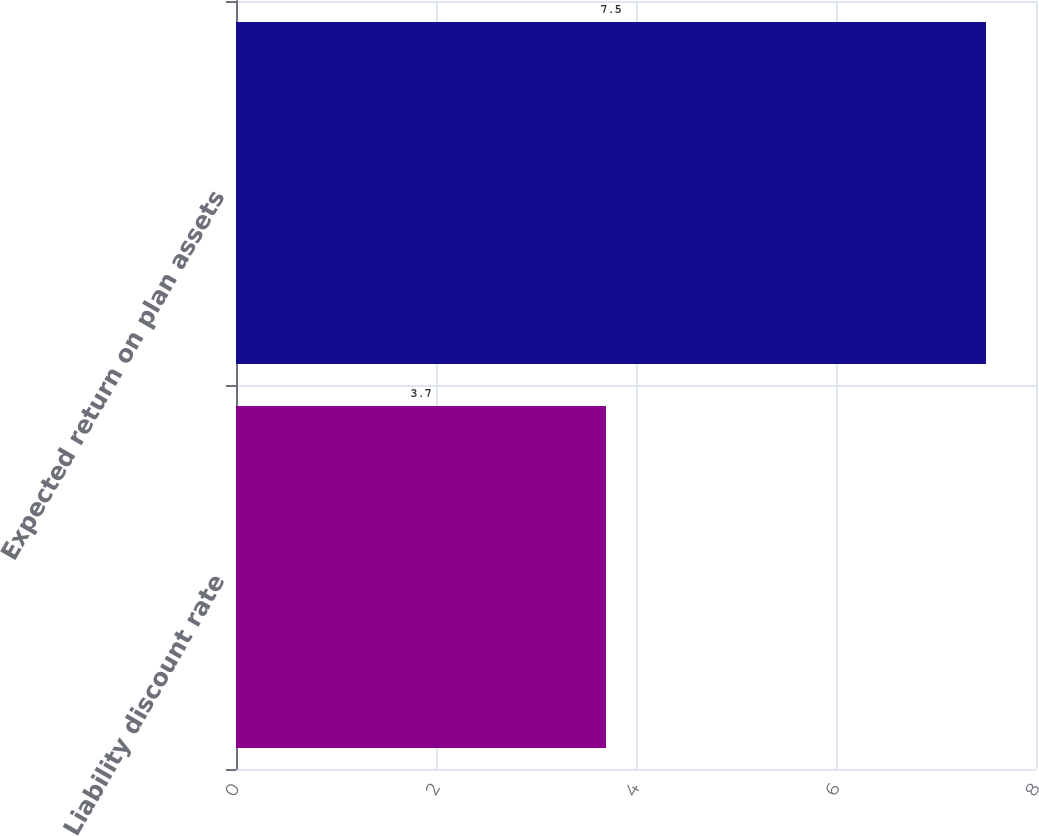<chart> <loc_0><loc_0><loc_500><loc_500><bar_chart><fcel>Liability discount rate<fcel>Expected return on plan assets<nl><fcel>3.7<fcel>7.5<nl></chart> 